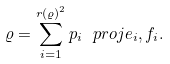<formula> <loc_0><loc_0><loc_500><loc_500>\varrho = \sum _ { i = 1 } ^ { r ( \varrho ) ^ { 2 } } p _ { i } \ p r o j { e _ { i } , f _ { i } } .</formula> 